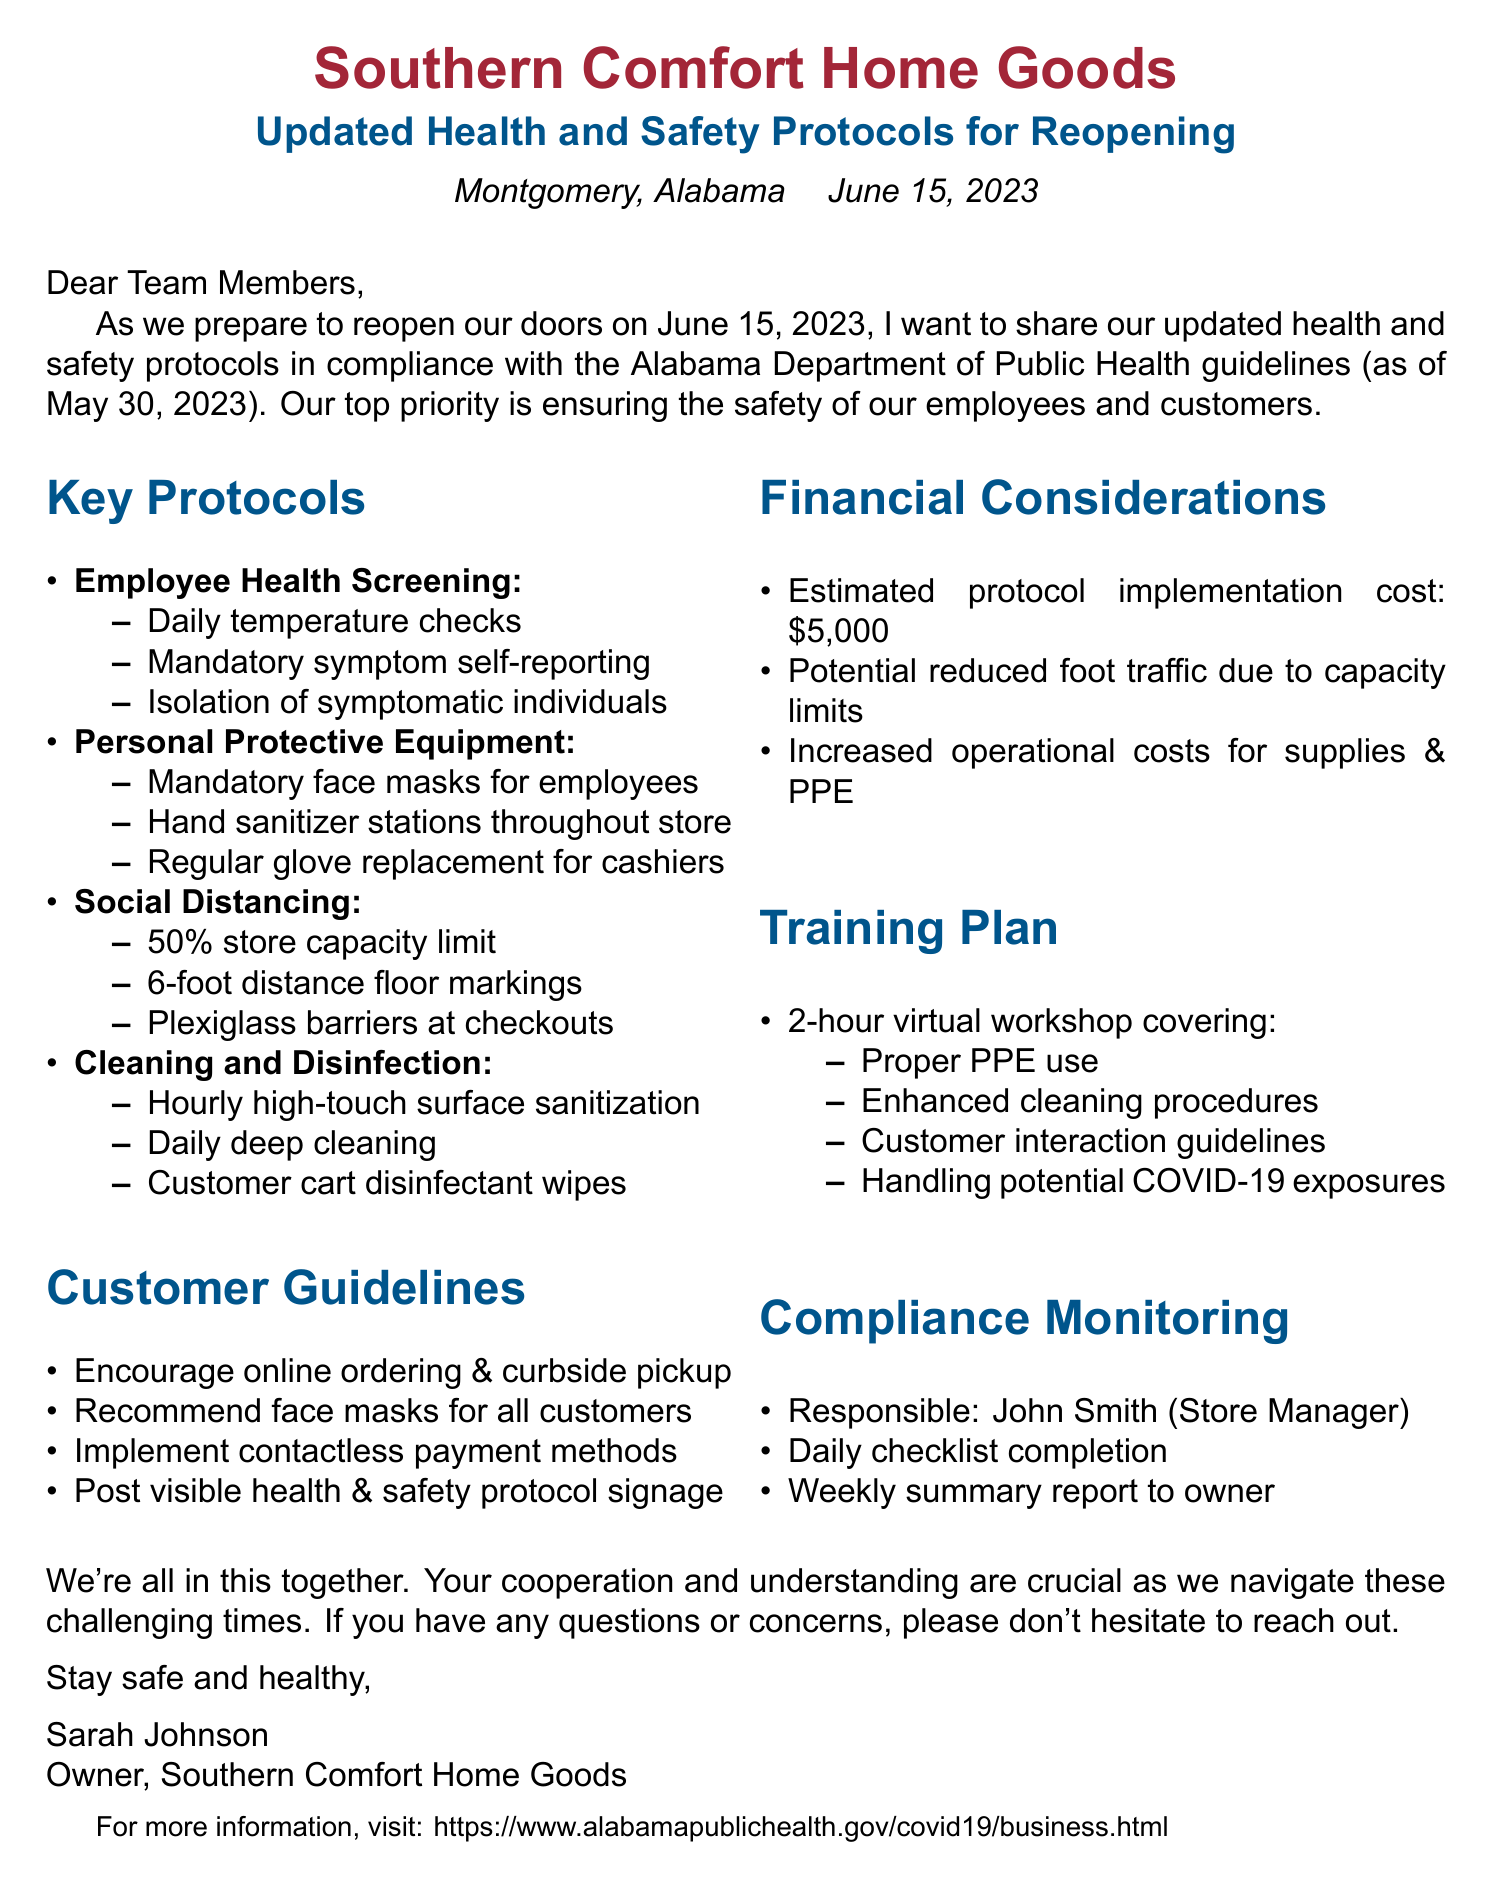What is the business name? The business name is stated clearly in the document's heading.
Answer: Southern Comfort Home Goods When is the date of reopening? The date of reopening is specified in the introduction of the memo.
Answer: June 15, 2023 What is the estimated cost of implementing new protocols? The estimated cost can be found in the financial considerations section of the document.
Answer: $5,000 Who is responsible for compliance monitoring? The compliance monitoring section names the responsible person for oversight.
Answer: John Smith What percentage of occupancy is the store limited to? The social distancing protocol specifies the store capacity limit.
Answer: 50% What training method is used for the staff? The training plan outlines the method used for staff training sessions.
Answer: Virtual workshop What is the duration of the training plan? The duration of the training plan is specified in the training plan section.
Answer: 2 hours What should customers use for cleaning shopping carts? The cleaning and disinfection section lists the provisions for customers.
Answer: Disinfectant wipes How often will high-touch surfaces be sanitized? The cleaning protocol in the memo specifies the frequency of sanitation.
Answer: Hourly 